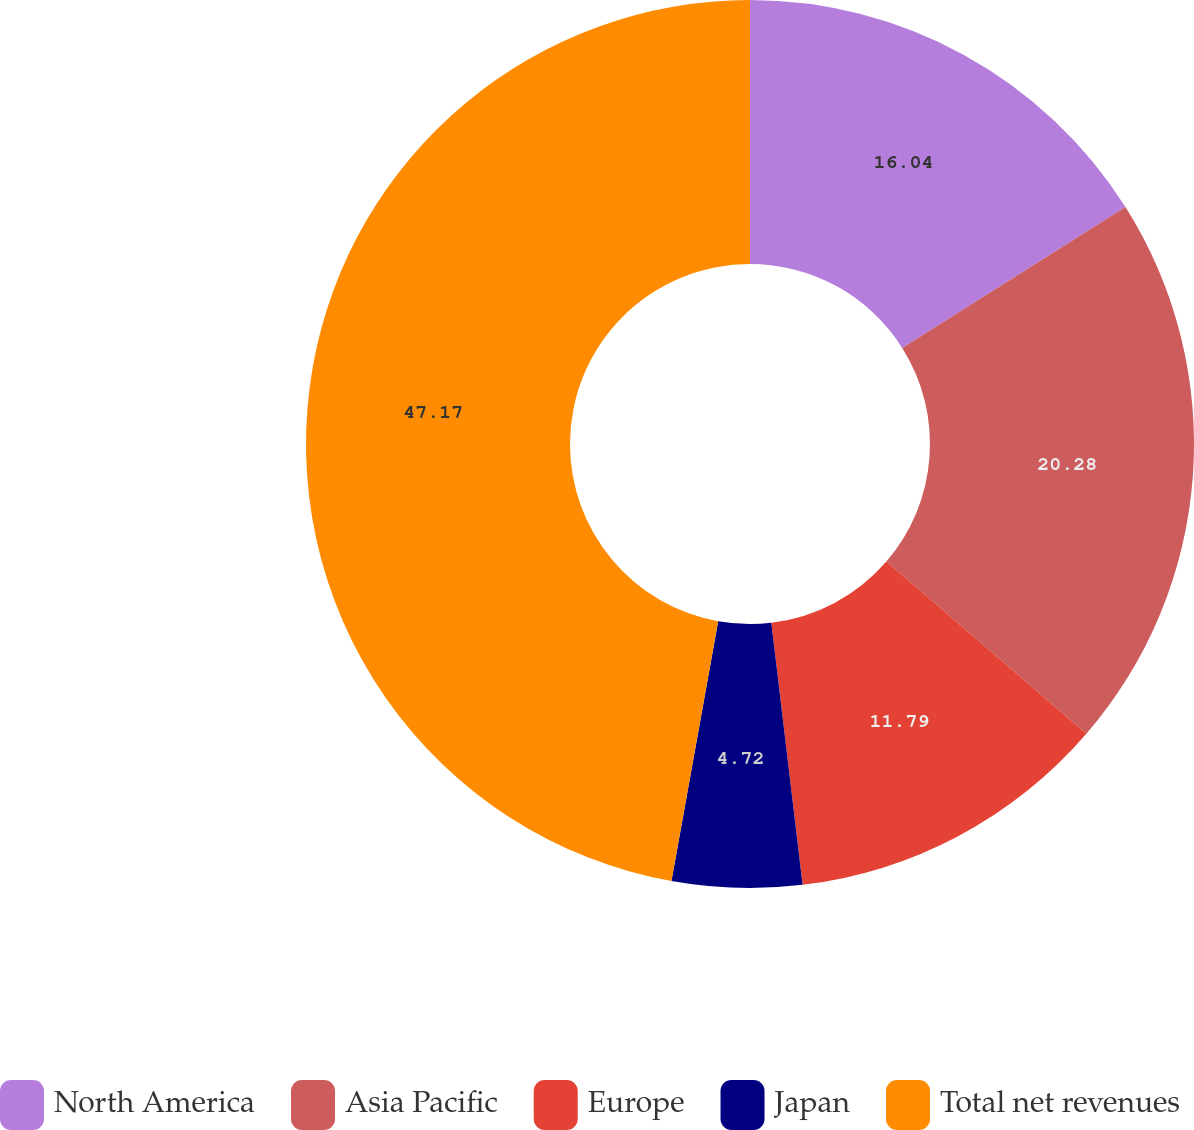Convert chart. <chart><loc_0><loc_0><loc_500><loc_500><pie_chart><fcel>North America<fcel>Asia Pacific<fcel>Europe<fcel>Japan<fcel>Total net revenues<nl><fcel>16.04%<fcel>20.28%<fcel>11.79%<fcel>4.72%<fcel>47.17%<nl></chart> 